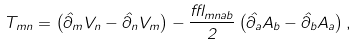<formula> <loc_0><loc_0><loc_500><loc_500>T _ { m n } = \left ( \hat { \partial } _ { m } V _ { n } - \hat { \partial } _ { n } V _ { m } \right ) - \frac { \epsilon _ { m n a b } } { 2 } \left ( \hat { \partial } _ { a } A _ { b } - \hat { \partial } _ { b } A _ { a } \right ) ,</formula> 